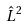Convert formula to latex. <formula><loc_0><loc_0><loc_500><loc_500>\hat { L } ^ { 2 }</formula> 